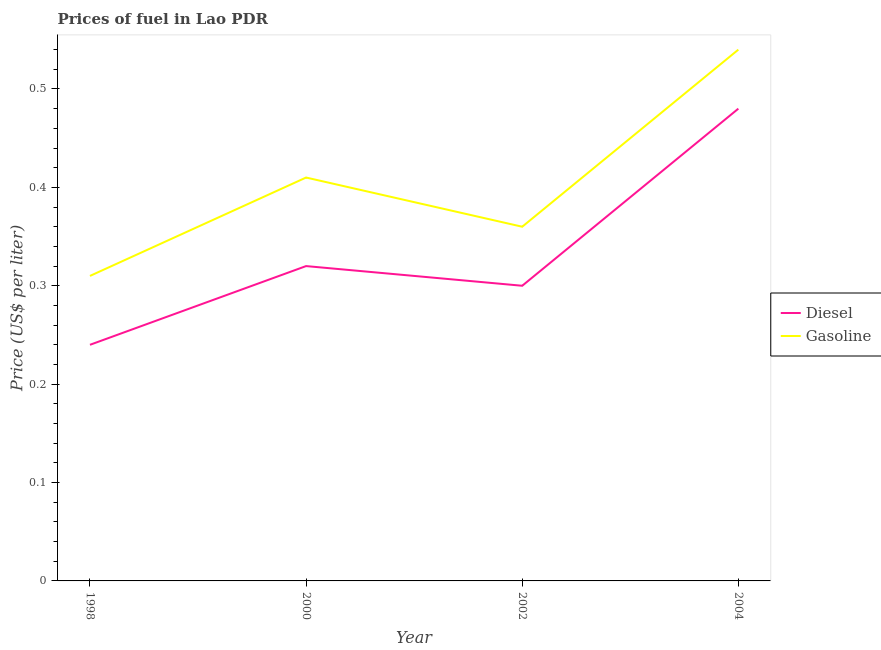Is the number of lines equal to the number of legend labels?
Offer a terse response. Yes. What is the diesel price in 2004?
Provide a short and direct response. 0.48. Across all years, what is the maximum diesel price?
Your answer should be compact. 0.48. Across all years, what is the minimum gasoline price?
Provide a short and direct response. 0.31. What is the total diesel price in the graph?
Make the answer very short. 1.34. What is the difference between the diesel price in 1998 and that in 2000?
Offer a terse response. -0.08. What is the difference between the gasoline price in 2004 and the diesel price in 1998?
Ensure brevity in your answer.  0.3. What is the average gasoline price per year?
Your answer should be compact. 0.41. In the year 2002, what is the difference between the gasoline price and diesel price?
Provide a succinct answer. 0.06. In how many years, is the diesel price greater than 0.24000000000000002 US$ per litre?
Make the answer very short. 3. What is the ratio of the gasoline price in 2000 to that in 2004?
Your answer should be very brief. 0.76. Is the difference between the diesel price in 2000 and 2004 greater than the difference between the gasoline price in 2000 and 2004?
Offer a terse response. No. What is the difference between the highest and the second highest diesel price?
Make the answer very short. 0.16. What is the difference between the highest and the lowest diesel price?
Offer a very short reply. 0.24. In how many years, is the gasoline price greater than the average gasoline price taken over all years?
Your response must be concise. 2. How many lines are there?
Your response must be concise. 2. What is the difference between two consecutive major ticks on the Y-axis?
Keep it short and to the point. 0.1. Are the values on the major ticks of Y-axis written in scientific E-notation?
Provide a short and direct response. No. How are the legend labels stacked?
Your response must be concise. Vertical. What is the title of the graph?
Keep it short and to the point. Prices of fuel in Lao PDR. Does "Public credit registry" appear as one of the legend labels in the graph?
Your response must be concise. No. What is the label or title of the Y-axis?
Offer a very short reply. Price (US$ per liter). What is the Price (US$ per liter) in Diesel in 1998?
Keep it short and to the point. 0.24. What is the Price (US$ per liter) of Gasoline in 1998?
Your response must be concise. 0.31. What is the Price (US$ per liter) in Diesel in 2000?
Provide a short and direct response. 0.32. What is the Price (US$ per liter) of Gasoline in 2000?
Provide a succinct answer. 0.41. What is the Price (US$ per liter) of Gasoline in 2002?
Your response must be concise. 0.36. What is the Price (US$ per liter) in Diesel in 2004?
Provide a succinct answer. 0.48. What is the Price (US$ per liter) of Gasoline in 2004?
Ensure brevity in your answer.  0.54. Across all years, what is the maximum Price (US$ per liter) in Diesel?
Your answer should be compact. 0.48. Across all years, what is the maximum Price (US$ per liter) in Gasoline?
Provide a short and direct response. 0.54. Across all years, what is the minimum Price (US$ per liter) of Diesel?
Ensure brevity in your answer.  0.24. Across all years, what is the minimum Price (US$ per liter) in Gasoline?
Ensure brevity in your answer.  0.31. What is the total Price (US$ per liter) in Diesel in the graph?
Give a very brief answer. 1.34. What is the total Price (US$ per liter) of Gasoline in the graph?
Offer a terse response. 1.62. What is the difference between the Price (US$ per liter) in Diesel in 1998 and that in 2000?
Keep it short and to the point. -0.08. What is the difference between the Price (US$ per liter) in Diesel in 1998 and that in 2002?
Keep it short and to the point. -0.06. What is the difference between the Price (US$ per liter) in Gasoline in 1998 and that in 2002?
Your answer should be compact. -0.05. What is the difference between the Price (US$ per liter) in Diesel in 1998 and that in 2004?
Make the answer very short. -0.24. What is the difference between the Price (US$ per liter) of Gasoline in 1998 and that in 2004?
Ensure brevity in your answer.  -0.23. What is the difference between the Price (US$ per liter) of Diesel in 2000 and that in 2004?
Provide a short and direct response. -0.16. What is the difference between the Price (US$ per liter) of Gasoline in 2000 and that in 2004?
Keep it short and to the point. -0.13. What is the difference between the Price (US$ per liter) of Diesel in 2002 and that in 2004?
Offer a very short reply. -0.18. What is the difference between the Price (US$ per liter) of Gasoline in 2002 and that in 2004?
Offer a terse response. -0.18. What is the difference between the Price (US$ per liter) of Diesel in 1998 and the Price (US$ per liter) of Gasoline in 2000?
Your answer should be very brief. -0.17. What is the difference between the Price (US$ per liter) of Diesel in 1998 and the Price (US$ per liter) of Gasoline in 2002?
Your response must be concise. -0.12. What is the difference between the Price (US$ per liter) of Diesel in 1998 and the Price (US$ per liter) of Gasoline in 2004?
Your answer should be compact. -0.3. What is the difference between the Price (US$ per liter) of Diesel in 2000 and the Price (US$ per liter) of Gasoline in 2002?
Your answer should be compact. -0.04. What is the difference between the Price (US$ per liter) in Diesel in 2000 and the Price (US$ per liter) in Gasoline in 2004?
Your answer should be compact. -0.22. What is the difference between the Price (US$ per liter) in Diesel in 2002 and the Price (US$ per liter) in Gasoline in 2004?
Provide a short and direct response. -0.24. What is the average Price (US$ per liter) of Diesel per year?
Provide a succinct answer. 0.34. What is the average Price (US$ per liter) of Gasoline per year?
Keep it short and to the point. 0.41. In the year 1998, what is the difference between the Price (US$ per liter) of Diesel and Price (US$ per liter) of Gasoline?
Keep it short and to the point. -0.07. In the year 2000, what is the difference between the Price (US$ per liter) of Diesel and Price (US$ per liter) of Gasoline?
Give a very brief answer. -0.09. In the year 2002, what is the difference between the Price (US$ per liter) in Diesel and Price (US$ per liter) in Gasoline?
Ensure brevity in your answer.  -0.06. In the year 2004, what is the difference between the Price (US$ per liter) in Diesel and Price (US$ per liter) in Gasoline?
Your answer should be very brief. -0.06. What is the ratio of the Price (US$ per liter) in Diesel in 1998 to that in 2000?
Give a very brief answer. 0.75. What is the ratio of the Price (US$ per liter) of Gasoline in 1998 to that in 2000?
Ensure brevity in your answer.  0.76. What is the ratio of the Price (US$ per liter) in Diesel in 1998 to that in 2002?
Provide a short and direct response. 0.8. What is the ratio of the Price (US$ per liter) of Gasoline in 1998 to that in 2002?
Your response must be concise. 0.86. What is the ratio of the Price (US$ per liter) in Diesel in 1998 to that in 2004?
Give a very brief answer. 0.5. What is the ratio of the Price (US$ per liter) of Gasoline in 1998 to that in 2004?
Your response must be concise. 0.57. What is the ratio of the Price (US$ per liter) of Diesel in 2000 to that in 2002?
Provide a short and direct response. 1.07. What is the ratio of the Price (US$ per liter) in Gasoline in 2000 to that in 2002?
Provide a succinct answer. 1.14. What is the ratio of the Price (US$ per liter) of Gasoline in 2000 to that in 2004?
Provide a succinct answer. 0.76. What is the ratio of the Price (US$ per liter) of Diesel in 2002 to that in 2004?
Keep it short and to the point. 0.62. What is the difference between the highest and the second highest Price (US$ per liter) of Diesel?
Make the answer very short. 0.16. What is the difference between the highest and the second highest Price (US$ per liter) in Gasoline?
Your answer should be very brief. 0.13. What is the difference between the highest and the lowest Price (US$ per liter) of Diesel?
Your response must be concise. 0.24. What is the difference between the highest and the lowest Price (US$ per liter) in Gasoline?
Ensure brevity in your answer.  0.23. 